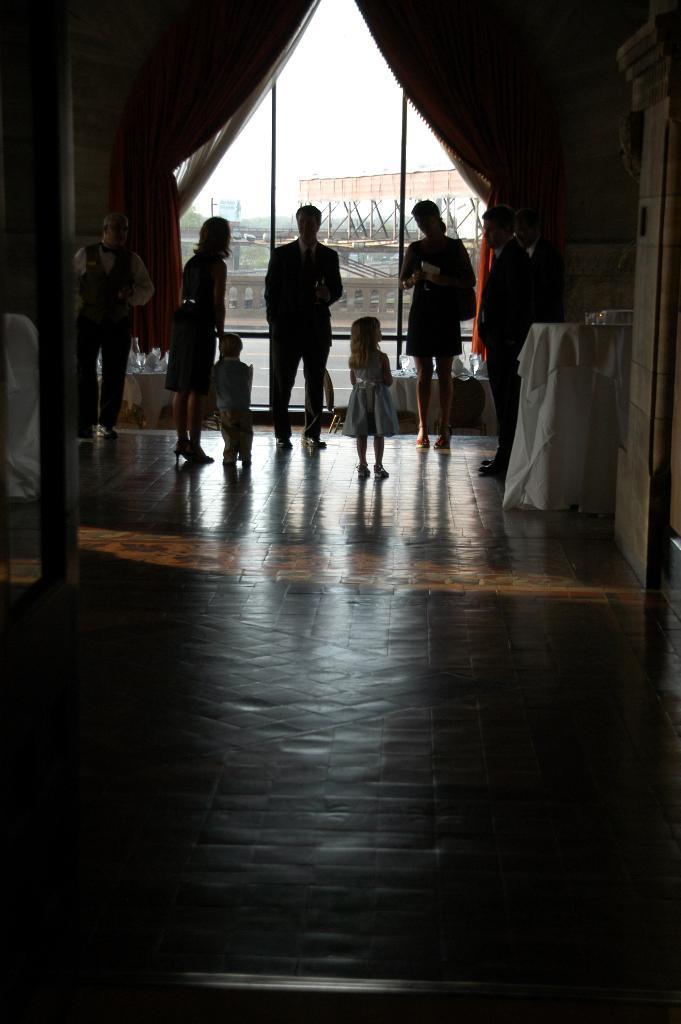Could you give a brief overview of what you see in this image? In this image there are a few people standing on the floor. On the right side of the image there is a table with some stuff on it. In the background there is a glass door and curtains. 